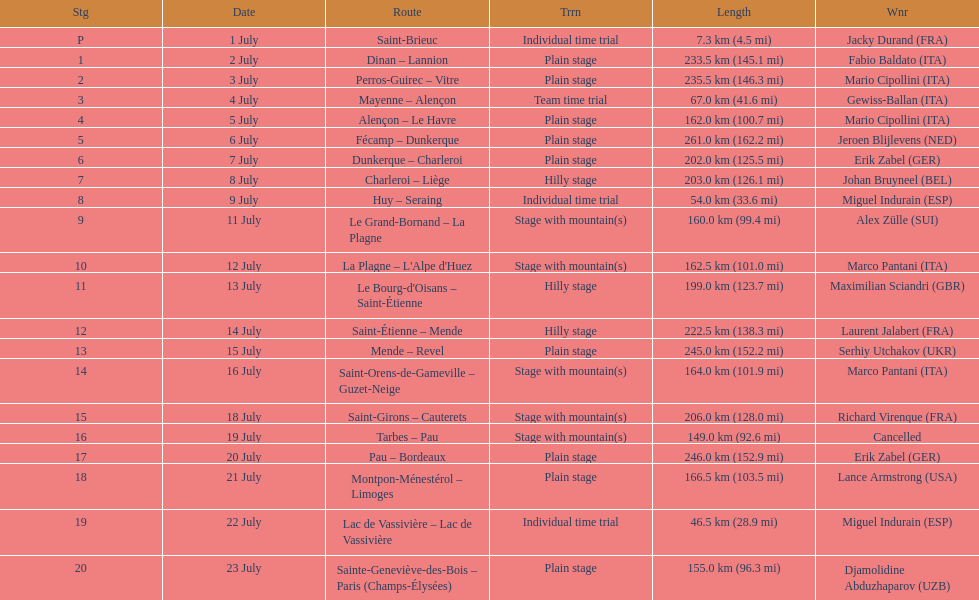How many routes have below 100 km total? 4. 